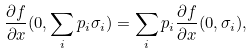<formula> <loc_0><loc_0><loc_500><loc_500>\frac { \partial f } { \partial x } ( 0 , \sum _ { i } p _ { i } \sigma _ { i } ) = \sum _ { i } p _ { i } \frac { \partial f } { \partial x } ( 0 , \sigma _ { i } ) ,</formula> 